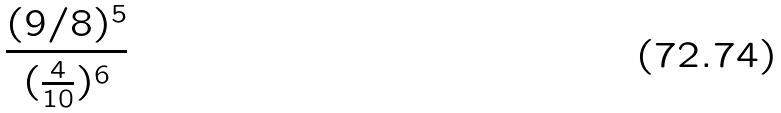<formula> <loc_0><loc_0><loc_500><loc_500>\frac { ( 9 / 8 ) ^ { 5 } } { ( \frac { 4 } { 1 0 } ) ^ { 6 } }</formula> 